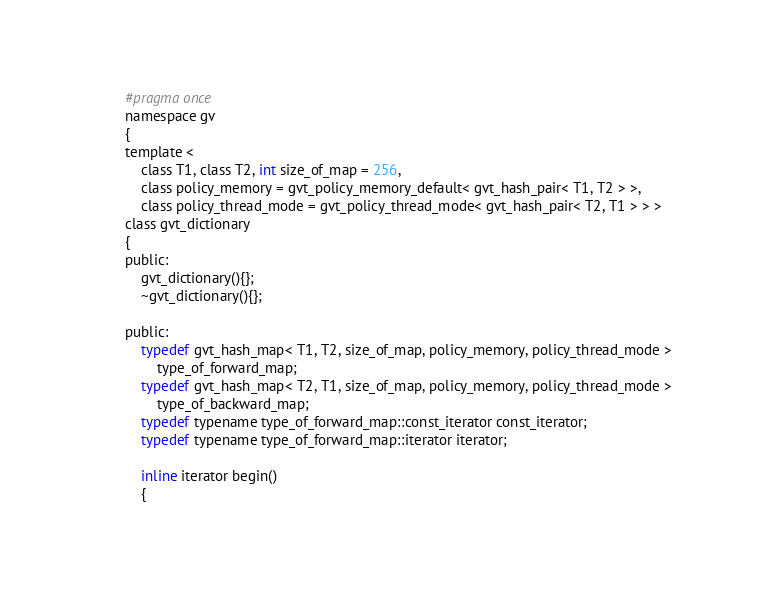Convert code to text. <code><loc_0><loc_0><loc_500><loc_500><_C_>#pragma once
namespace gv
{
template <
	class T1, class T2, int size_of_map = 256,
	class policy_memory = gvt_policy_memory_default< gvt_hash_pair< T1, T2 > >,
	class policy_thread_mode = gvt_policy_thread_mode< gvt_hash_pair< T2, T1 > > >
class gvt_dictionary
{
public:
	gvt_dictionary(){};
	~gvt_dictionary(){};

public:
	typedef gvt_hash_map< T1, T2, size_of_map, policy_memory, policy_thread_mode >
		type_of_forward_map;
	typedef gvt_hash_map< T2, T1, size_of_map, policy_memory, policy_thread_mode >
		type_of_backward_map;
	typedef typename type_of_forward_map::const_iterator const_iterator;
	typedef typename type_of_forward_map::iterator iterator;

	inline iterator begin()
	{</code> 